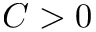Convert formula to latex. <formula><loc_0><loc_0><loc_500><loc_500>C > 0</formula> 